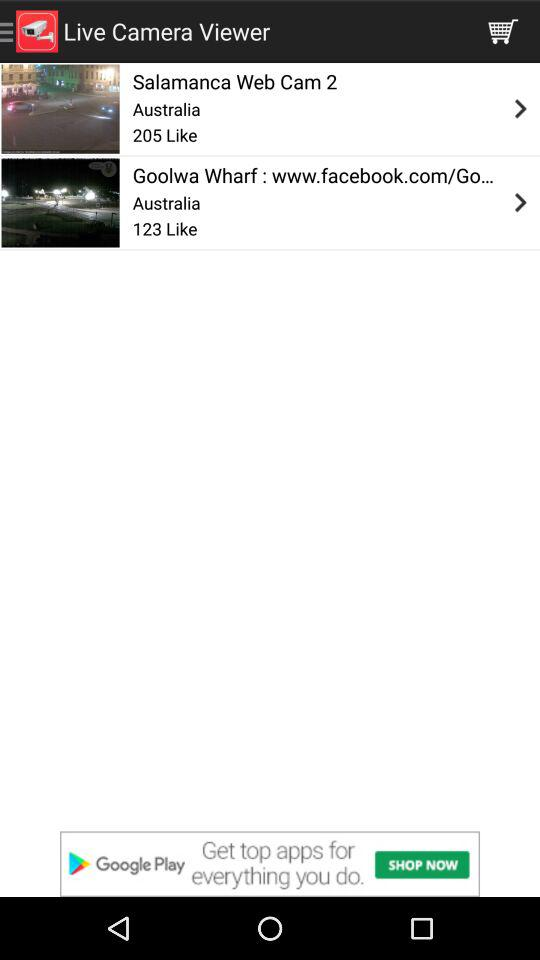The "Goolwa Wharf" is located in which country? The country is Australia. 